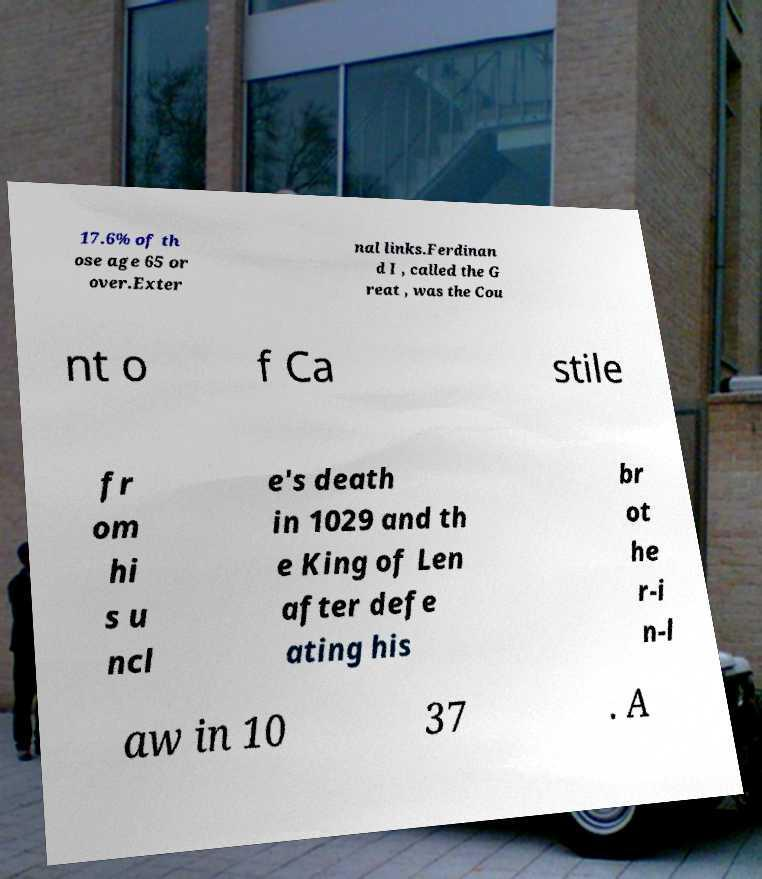Please read and relay the text visible in this image. What does it say? 17.6% of th ose age 65 or over.Exter nal links.Ferdinan d I , called the G reat , was the Cou nt o f Ca stile fr om hi s u ncl e's death in 1029 and th e King of Len after defe ating his br ot he r-i n-l aw in 10 37 . A 